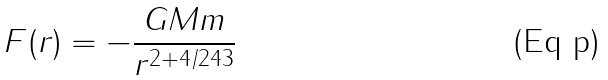Convert formula to latex. <formula><loc_0><loc_0><loc_500><loc_500>F ( r ) = - \frac { G M m } { r ^ { 2 + 4 / 2 4 3 } }</formula> 